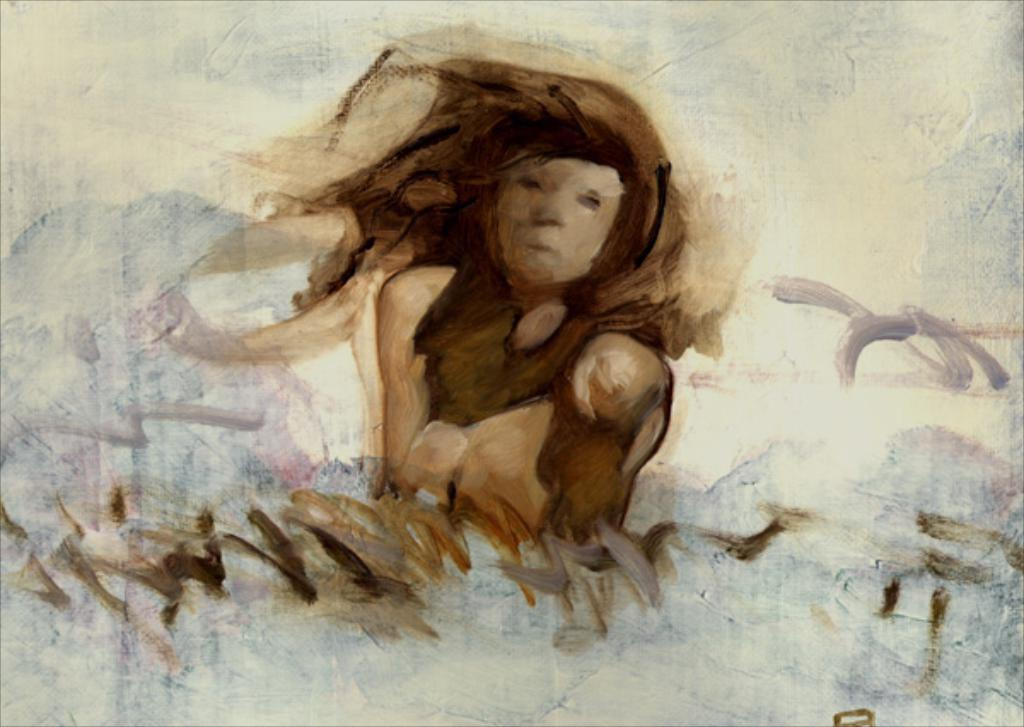What is the main subject of the image? The main subject of the image is a painting. What does the painting depict? The painting depicts a person. Where can you find the toy market in the image? There is no toy market present in the image. 